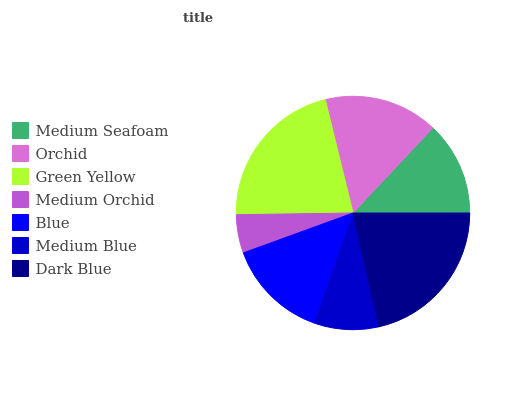Is Medium Orchid the minimum?
Answer yes or no. Yes. Is Dark Blue the maximum?
Answer yes or no. Yes. Is Orchid the minimum?
Answer yes or no. No. Is Orchid the maximum?
Answer yes or no. No. Is Orchid greater than Medium Seafoam?
Answer yes or no. Yes. Is Medium Seafoam less than Orchid?
Answer yes or no. Yes. Is Medium Seafoam greater than Orchid?
Answer yes or no. No. Is Orchid less than Medium Seafoam?
Answer yes or no. No. Is Blue the high median?
Answer yes or no. Yes. Is Blue the low median?
Answer yes or no. Yes. Is Green Yellow the high median?
Answer yes or no. No. Is Medium Seafoam the low median?
Answer yes or no. No. 